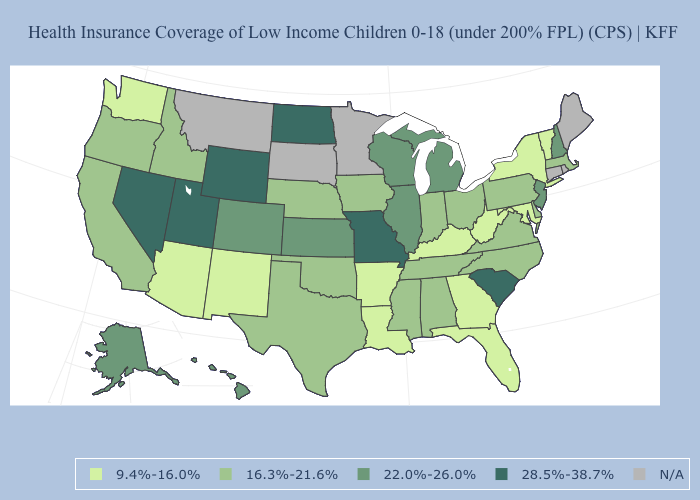Does North Dakota have the highest value in the MidWest?
Short answer required. Yes. Which states have the highest value in the USA?
Short answer required. Missouri, Nevada, North Dakota, South Carolina, Utah, Wyoming. Does the first symbol in the legend represent the smallest category?
Be succinct. Yes. Name the states that have a value in the range 9.4%-16.0%?
Keep it brief. Arizona, Arkansas, Florida, Georgia, Kentucky, Louisiana, Maryland, New Mexico, New York, Vermont, Washington, West Virginia. What is the value of South Carolina?
Answer briefly. 28.5%-38.7%. Does the map have missing data?
Be succinct. Yes. What is the lowest value in the USA?
Answer briefly. 9.4%-16.0%. Is the legend a continuous bar?
Keep it brief. No. Does Georgia have the lowest value in the South?
Short answer required. Yes. What is the value of Minnesota?
Give a very brief answer. N/A. Which states have the highest value in the USA?
Be succinct. Missouri, Nevada, North Dakota, South Carolina, Utah, Wyoming. What is the value of Kentucky?
Give a very brief answer. 9.4%-16.0%. What is the lowest value in the West?
Write a very short answer. 9.4%-16.0%. Does Idaho have the lowest value in the USA?
Write a very short answer. No. 